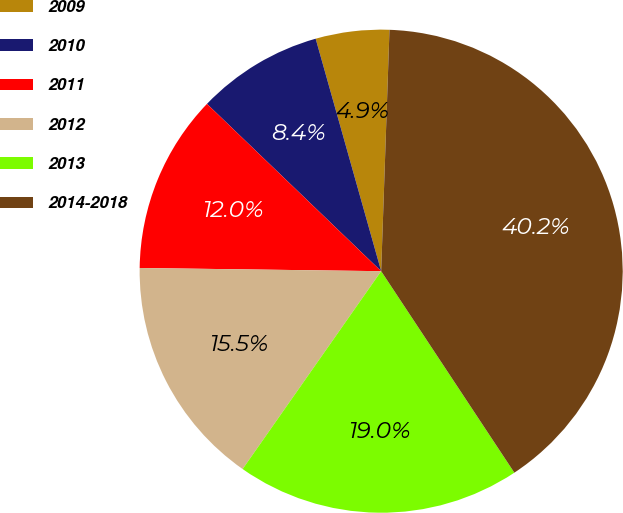Convert chart. <chart><loc_0><loc_0><loc_500><loc_500><pie_chart><fcel>2009<fcel>2010<fcel>2011<fcel>2012<fcel>2013<fcel>2014-2018<nl><fcel>4.92%<fcel>8.45%<fcel>11.97%<fcel>15.49%<fcel>19.02%<fcel>40.16%<nl></chart> 